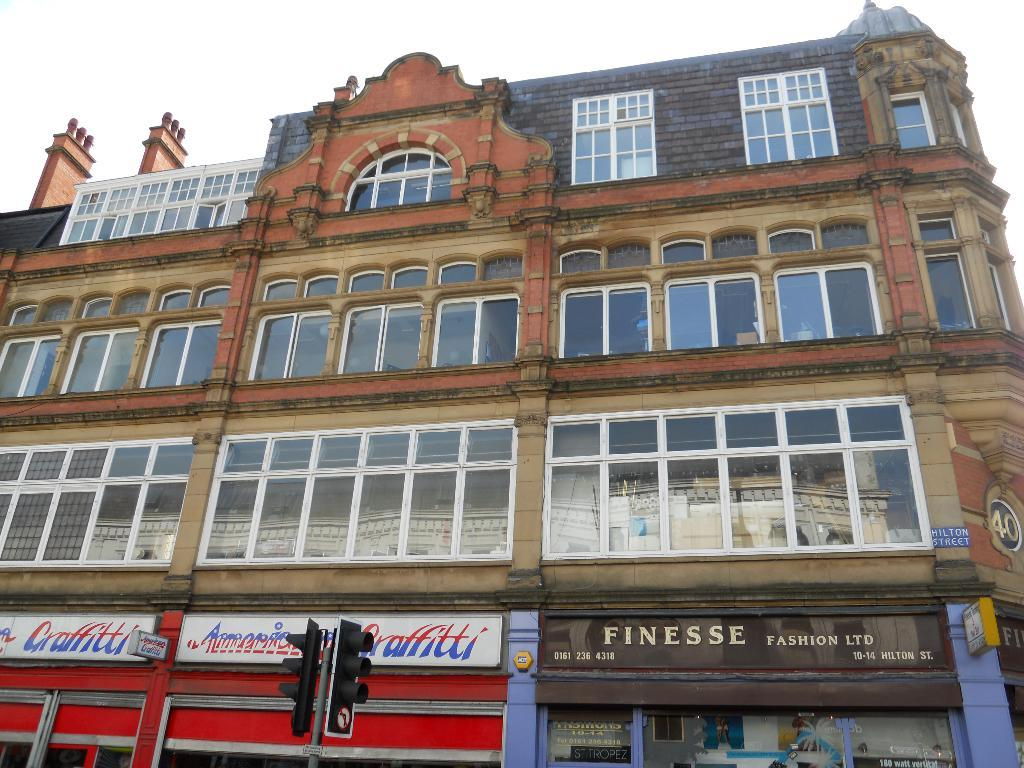What type of structure is visible in the image? There is a building in the image. What feature can be observed on the building? The building has glass windows. What objects are present in the foreground of the image? There are signal lights and hoardings in the foreground of the image. How would you describe the sky in the image? The sky is cloudy. What type of substance is being used to make the quilt in the image? There is no quilt present in the image, so it is not possible to determine what substance might be used to make it. 